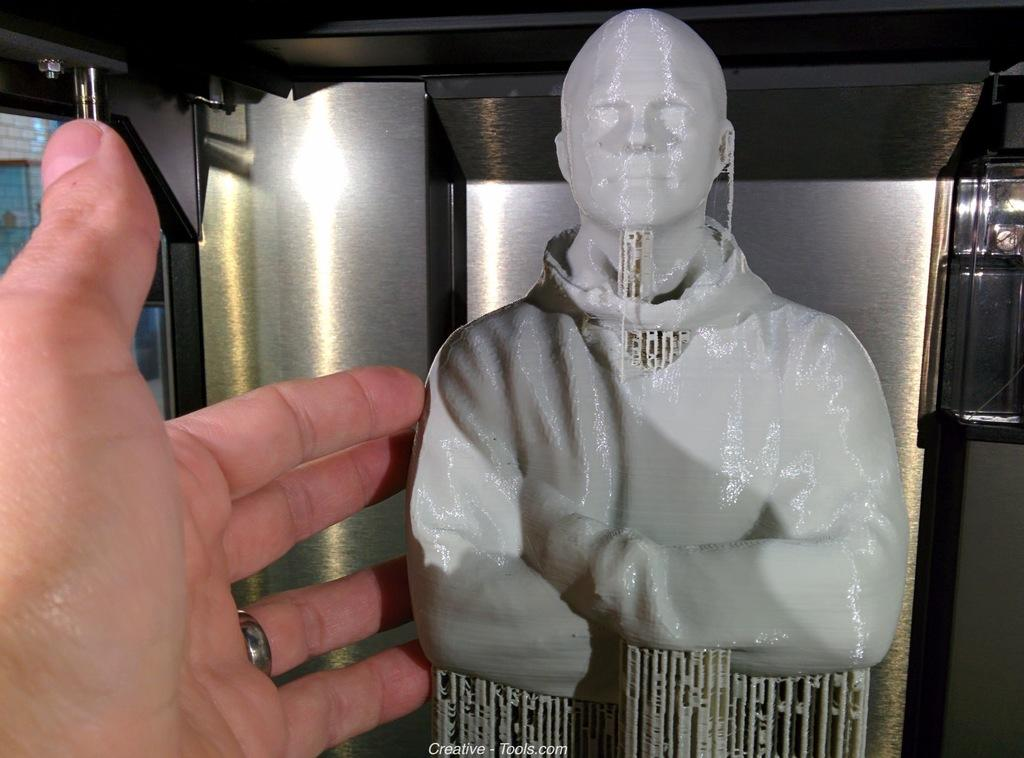What is the main subject in the image? There is a statue in the image. Can you describe any human elements in the image? A person's hand is visible in the image. What architectural features can be seen in the background of the image? There is a pillar and a wall in the background of the image. How many clocks are hanging on the wall in the image? There are no clocks visible in the image. What suggestion does the statue make to the person in the image? The statue is not making any suggestions, as it is an inanimate object. 